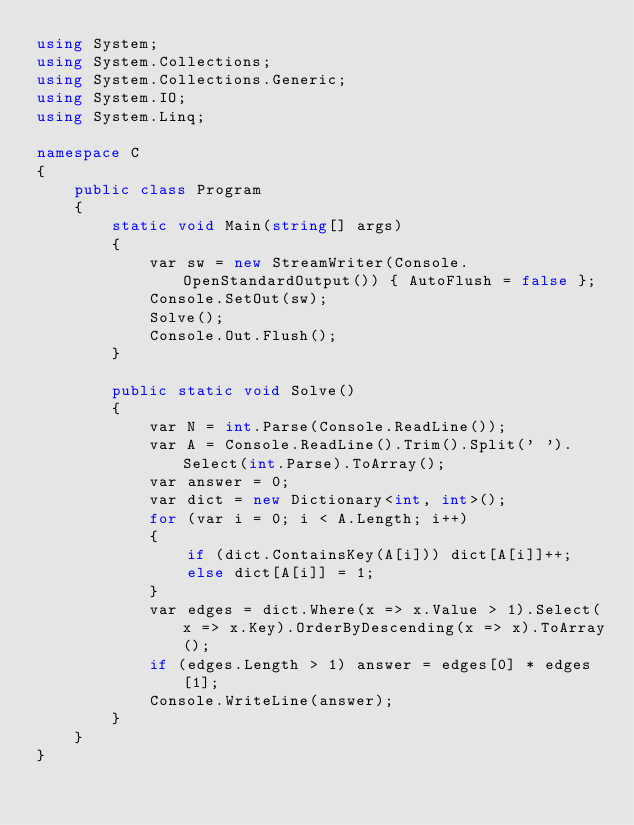Convert code to text. <code><loc_0><loc_0><loc_500><loc_500><_C#_>using System;
using System.Collections;
using System.Collections.Generic;
using System.IO;
using System.Linq;

namespace C
{
    public class Program
    {
        static void Main(string[] args)
        {
            var sw = new StreamWriter(Console.OpenStandardOutput()) { AutoFlush = false };
            Console.SetOut(sw);
            Solve();
            Console.Out.Flush();
        }

        public static void Solve()
        {
            var N = int.Parse(Console.ReadLine());
            var A = Console.ReadLine().Trim().Split(' ').Select(int.Parse).ToArray();
            var answer = 0;
            var dict = new Dictionary<int, int>();
            for (var i = 0; i < A.Length; i++)
            {
                if (dict.ContainsKey(A[i])) dict[A[i]]++;
                else dict[A[i]] = 1;
            }
            var edges = dict.Where(x => x.Value > 1).Select(x => x.Key).OrderByDescending(x => x).ToArray();
            if (edges.Length > 1) answer = edges[0] * edges[1];
            Console.WriteLine(answer);
        }
    }
}
</code> 